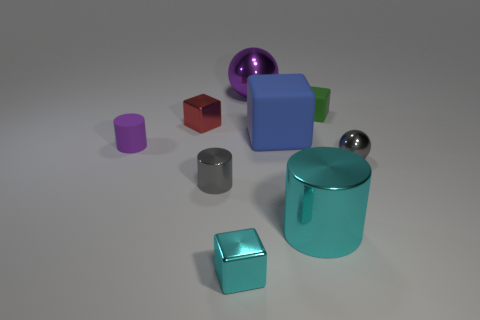What number of other objects are the same shape as the tiny purple thing?
Provide a short and direct response. 2. There is a small metal object on the right side of the cyan cube; is its color the same as the metal cylinder that is left of the tiny cyan block?
Provide a succinct answer. Yes. How big is the cylinder that is behind the gray thing that is on the right side of the large metallic object behind the big blue object?
Offer a very short reply. Small. The big object that is both on the left side of the large cylinder and in front of the large purple shiny object has what shape?
Ensure brevity in your answer.  Cube. Are there the same number of green rubber objects that are behind the large blue matte object and tiny gray metal cylinders behind the large purple metal sphere?
Keep it short and to the point. No. Are there any tiny green cubes made of the same material as the small purple object?
Offer a terse response. Yes. Is the material of the cyan object that is on the left side of the large purple ball the same as the red object?
Your answer should be very brief. Yes. There is a thing that is both to the left of the cyan cylinder and in front of the gray cylinder; how big is it?
Provide a short and direct response. Small. The large ball is what color?
Offer a terse response. Purple. How many big blue metallic balls are there?
Offer a very short reply. 0. 